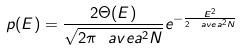<formula> <loc_0><loc_0><loc_500><loc_500>p ( E ) = \frac { 2 \Theta ( E ) } { \sqrt { 2 \pi \ a v e { a ^ { 2 } } N } } e ^ { - \frac { E ^ { 2 } } { 2 \ a v e { a ^ { 2 } } N } }</formula> 